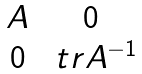<formula> <loc_0><loc_0><loc_500><loc_500>\begin{matrix} A & 0 \\ 0 & \ t r A ^ { - 1 } \end{matrix}</formula> 